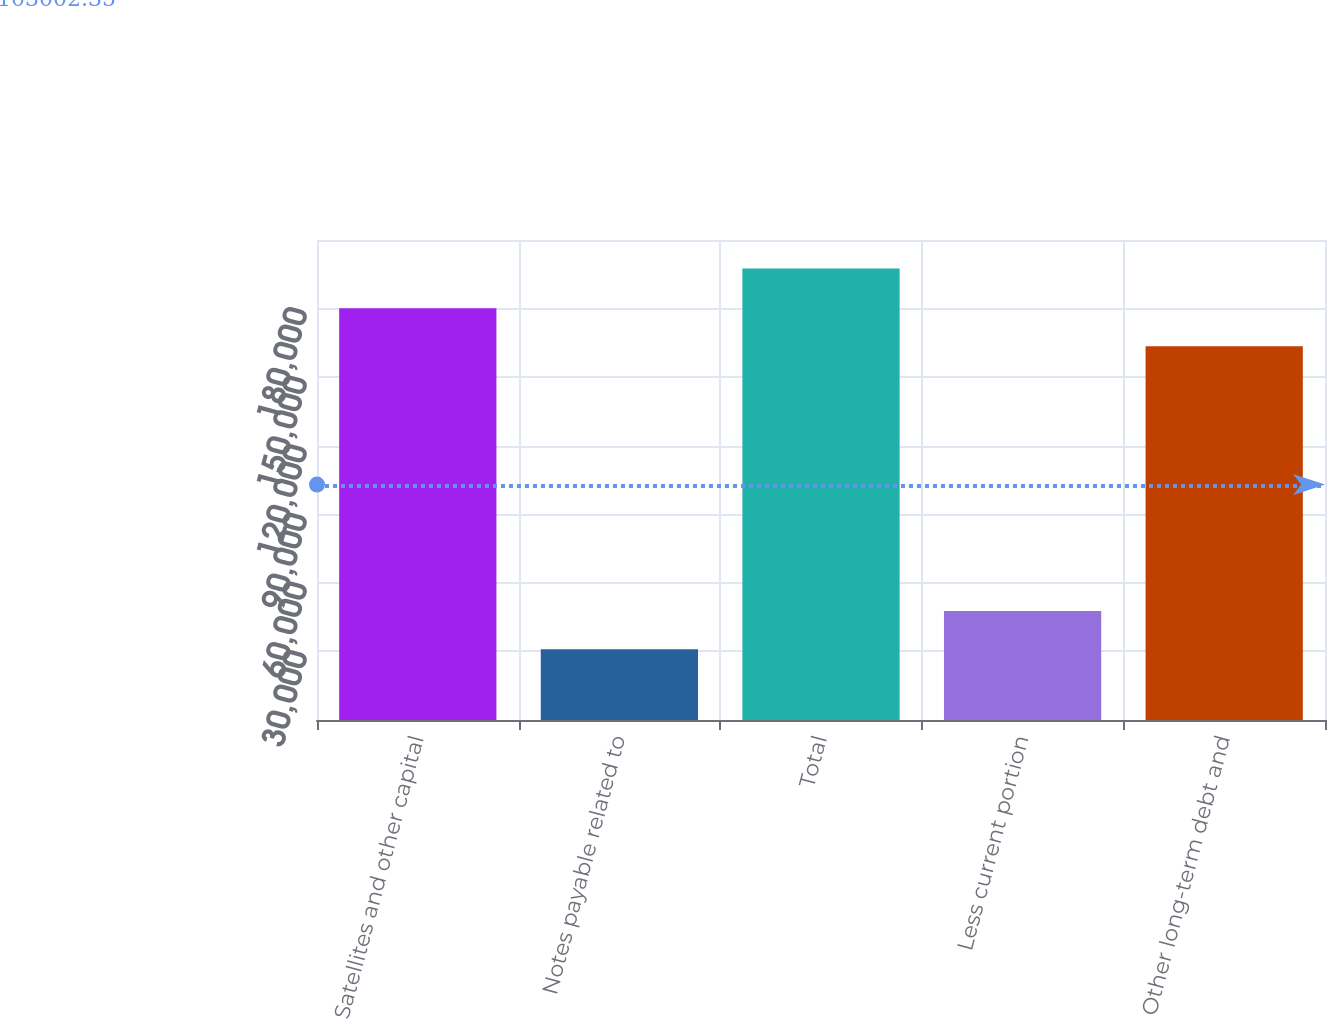Convert chart. <chart><loc_0><loc_0><loc_500><loc_500><bar_chart><fcel>Satellites and other capital<fcel>Notes payable related to<fcel>Total<fcel>Less current portion<fcel>Other long-term debt and<nl><fcel>180137<fcel>30996<fcel>197488<fcel>47645.2<fcel>163488<nl></chart> 